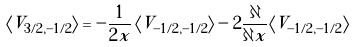Convert formula to latex. <formula><loc_0><loc_0><loc_500><loc_500>\langle V _ { 3 / 2 , - 1 / 2 } \rangle = - \frac { 1 } { 2 x } \left \langle V _ { - 1 / 2 , - 1 / 2 } \right \rangle - 2 \frac { \partial } { \partial x } \langle V _ { - 1 / 2 , - 1 / 2 } \rangle</formula> 